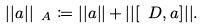<formula> <loc_0><loc_0><loc_500><loc_500>| | a | | _ { \ A } \coloneqq | | a | | + | | [ \ D , a ] | | .</formula> 